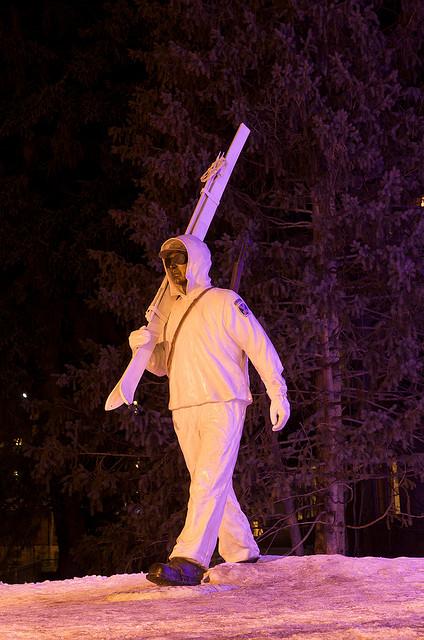What color is the man's white suit?
Short answer required. White. What is this person holding?
Quick response, please. Skis. Is the man holding a gun?
Write a very short answer. No. Where is this man going?
Concise answer only. Skiing. What sport are they playing?
Give a very brief answer. Skiing. 